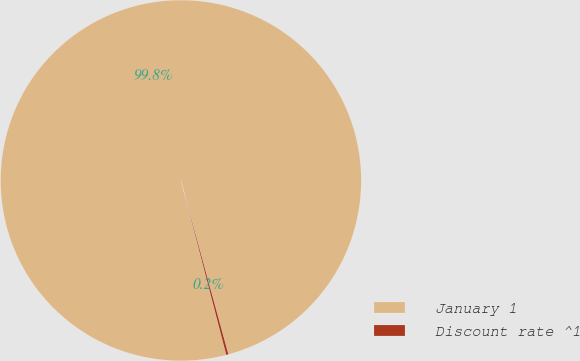<chart> <loc_0><loc_0><loc_500><loc_500><pie_chart><fcel>January 1<fcel>Discount rate ^1<nl><fcel>99.79%<fcel>0.21%<nl></chart> 